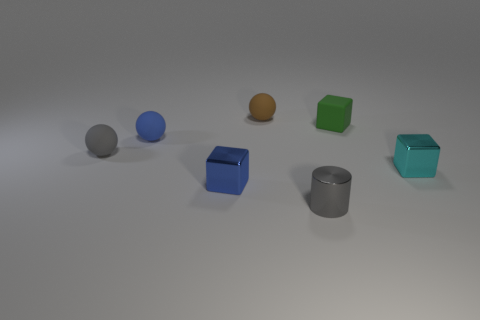There is a rubber sphere behind the blue rubber ball; what is its color?
Give a very brief answer. Brown. What number of tiny cyan shiny blocks are on the left side of the small gray object that is in front of the gray object that is behind the cylinder?
Make the answer very short. 0. There is a thing behind the rubber cube; what number of small blue metallic things are to the left of it?
Give a very brief answer. 1. There is a small brown sphere; how many shiny blocks are right of it?
Make the answer very short. 1. How many other objects are the same size as the brown thing?
Ensure brevity in your answer.  6. There is a gray object that is behind the small cyan object; what is its shape?
Offer a terse response. Sphere. The metal block to the left of the small brown rubber object that is behind the cyan metallic object is what color?
Offer a terse response. Blue. What number of things are things in front of the small gray ball or tiny matte cylinders?
Provide a short and direct response. 3. There is a brown thing; does it have the same size as the gray object behind the metallic cylinder?
Provide a succinct answer. Yes. How many tiny objects are purple balls or blue spheres?
Your answer should be compact. 1. 